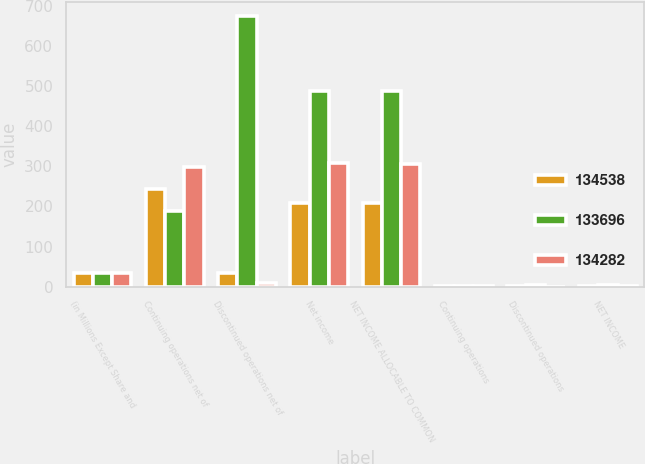Convert chart to OTSL. <chart><loc_0><loc_0><loc_500><loc_500><stacked_bar_chart><ecel><fcel>(in Millions Except Share and<fcel>Continuing operations net of<fcel>Discontinued operations net of<fcel>Net income<fcel>NET INCOME ALLOCABLE TO COMMON<fcel>Continuing operations<fcel>Discontinued operations<fcel>NET INCOME<nl><fcel>134538<fcel>33.7<fcel>242.8<fcel>33.7<fcel>209.1<fcel>208.4<fcel>1.81<fcel>0.25<fcel>1.56<nl><fcel>133696<fcel>33.7<fcel>187.4<fcel>676.4<fcel>489<fcel>489<fcel>1.4<fcel>5.06<fcel>3.66<nl><fcel>134282<fcel>33.7<fcel>298.2<fcel>9.3<fcel>307.5<fcel>306.6<fcel>2.23<fcel>0.07<fcel>2.3<nl></chart> 